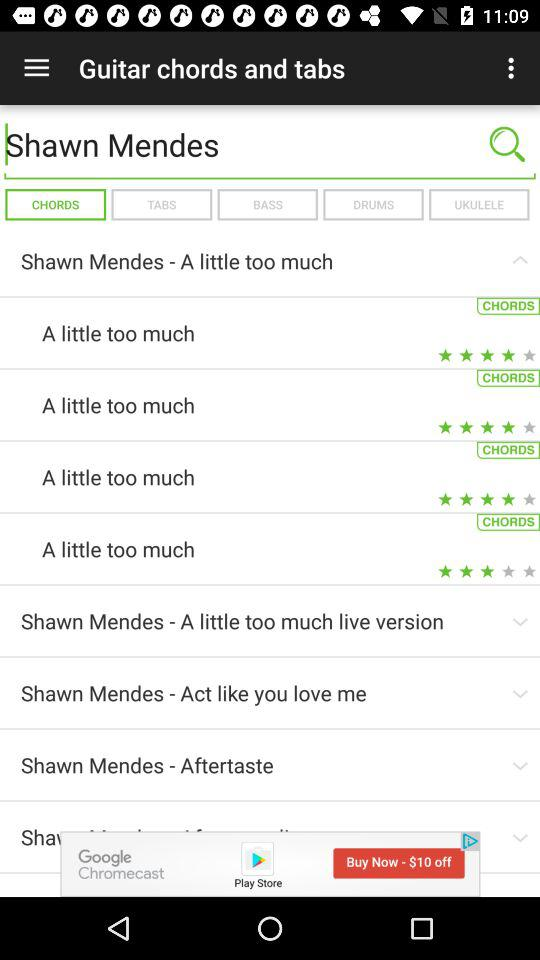Which option is selected? The selected option is "CHORDS". 